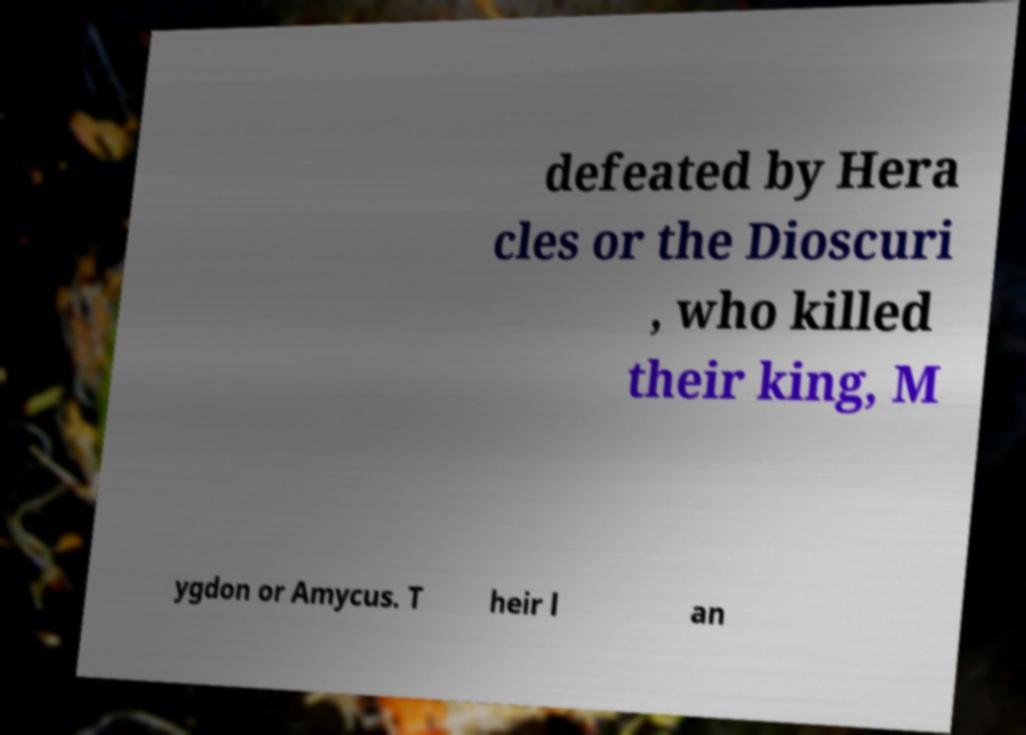Please identify and transcribe the text found in this image. defeated by Hera cles or the Dioscuri , who killed their king, M ygdon or Amycus. T heir l an 